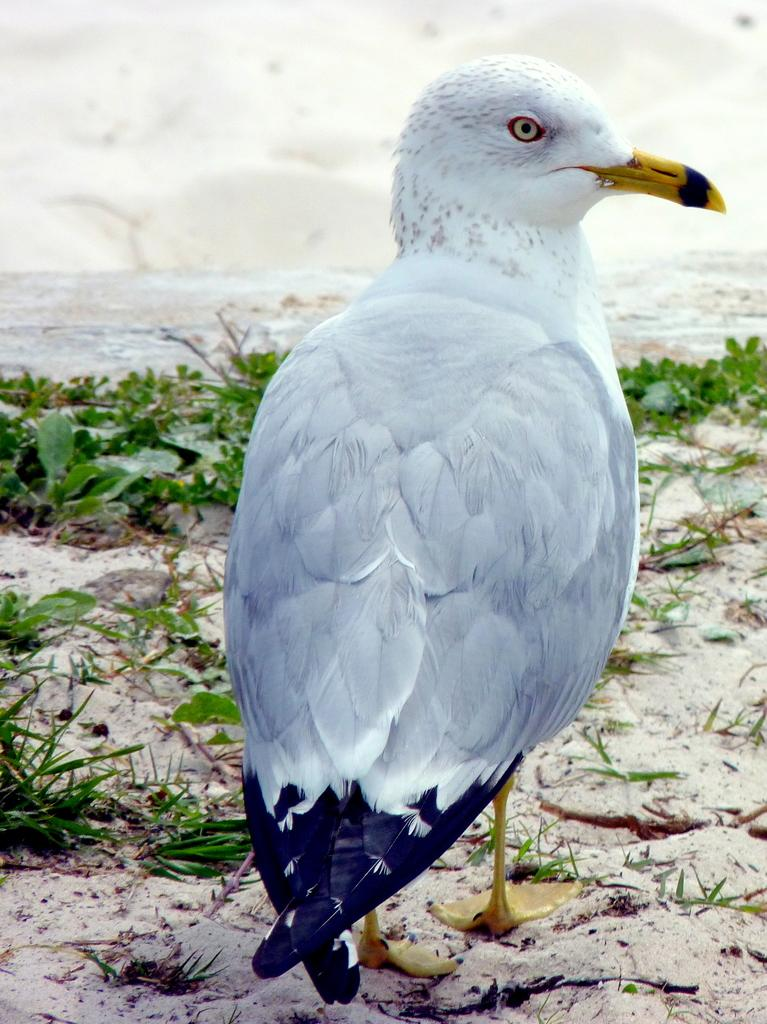What type of animal is on the ground in the image? There is a bird on the ground in the image. What else can be seen in the image besides the bird? There are plants and water visible in the image. What color is the background of the image? The background of the image is white. What type of coil can be seen in the image? There is no coil present in the image. What country is depicted in the image? The image does not depict any specific country. 